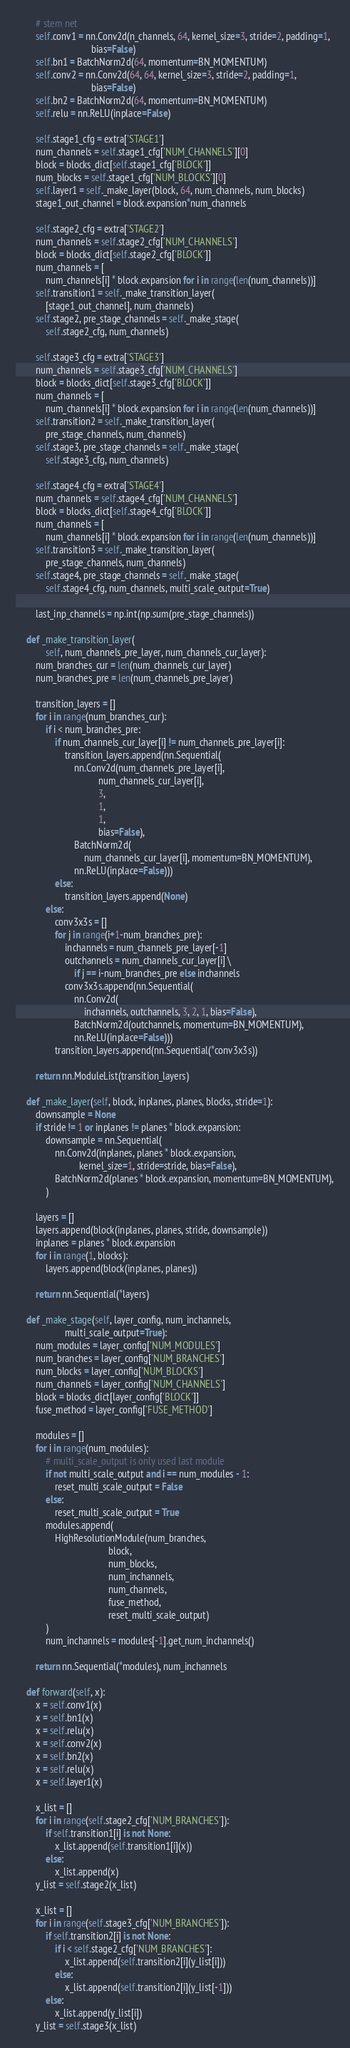<code> <loc_0><loc_0><loc_500><loc_500><_Python_>
        # stem net
        self.conv1 = nn.Conv2d(n_channels, 64, kernel_size=3, stride=2, padding=1,
                               bias=False)
        self.bn1 = BatchNorm2d(64, momentum=BN_MOMENTUM)
        self.conv2 = nn.Conv2d(64, 64, kernel_size=3, stride=2, padding=1,
                               bias=False)
        self.bn2 = BatchNorm2d(64, momentum=BN_MOMENTUM)
        self.relu = nn.ReLU(inplace=False)

        self.stage1_cfg = extra['STAGE1']
        num_channels = self.stage1_cfg['NUM_CHANNELS'][0]
        block = blocks_dict[self.stage1_cfg['BLOCK']]
        num_blocks = self.stage1_cfg['NUM_BLOCKS'][0]
        self.layer1 = self._make_layer(block, 64, num_channels, num_blocks)
        stage1_out_channel = block.expansion*num_channels

        self.stage2_cfg = extra['STAGE2']
        num_channels = self.stage2_cfg['NUM_CHANNELS']
        block = blocks_dict[self.stage2_cfg['BLOCK']]
        num_channels = [
            num_channels[i] * block.expansion for i in range(len(num_channels))]
        self.transition1 = self._make_transition_layer(
            [stage1_out_channel], num_channels)
        self.stage2, pre_stage_channels = self._make_stage(
            self.stage2_cfg, num_channels)

        self.stage3_cfg = extra['STAGE3']
        num_channels = self.stage3_cfg['NUM_CHANNELS']
        block = blocks_dict[self.stage3_cfg['BLOCK']]
        num_channels = [
            num_channels[i] * block.expansion for i in range(len(num_channels))]
        self.transition2 = self._make_transition_layer(
            pre_stage_channels, num_channels)
        self.stage3, pre_stage_channels = self._make_stage(
            self.stage3_cfg, num_channels)

        self.stage4_cfg = extra['STAGE4']
        num_channels = self.stage4_cfg['NUM_CHANNELS']
        block = blocks_dict[self.stage4_cfg['BLOCK']]
        num_channels = [
            num_channels[i] * block.expansion for i in range(len(num_channels))]
        self.transition3 = self._make_transition_layer(
            pre_stage_channels, num_channels)
        self.stage4, pre_stage_channels = self._make_stage(
            self.stage4_cfg, num_channels, multi_scale_output=True)
        
        last_inp_channels = np.int(np.sum(pre_stage_channels))
    
    def _make_transition_layer(
            self, num_channels_pre_layer, num_channels_cur_layer):
        num_branches_cur = len(num_channels_cur_layer)
        num_branches_pre = len(num_channels_pre_layer)

        transition_layers = []
        for i in range(num_branches_cur):
            if i < num_branches_pre:
                if num_channels_cur_layer[i] != num_channels_pre_layer[i]:
                    transition_layers.append(nn.Sequential(
                        nn.Conv2d(num_channels_pre_layer[i],
                                  num_channels_cur_layer[i],
                                  3,
                                  1,
                                  1,
                                  bias=False),
                        BatchNorm2d(
                            num_channels_cur_layer[i], momentum=BN_MOMENTUM),
                        nn.ReLU(inplace=False)))
                else:
                    transition_layers.append(None)
            else:
                conv3x3s = []
                for j in range(i+1-num_branches_pre):
                    inchannels = num_channels_pre_layer[-1]
                    outchannels = num_channels_cur_layer[i] \
                        if j == i-num_branches_pre else inchannels
                    conv3x3s.append(nn.Sequential(
                        nn.Conv2d(
                            inchannels, outchannels, 3, 2, 1, bias=False),
                        BatchNorm2d(outchannels, momentum=BN_MOMENTUM),
                        nn.ReLU(inplace=False)))
                transition_layers.append(nn.Sequential(*conv3x3s))

        return nn.ModuleList(transition_layers)

    def _make_layer(self, block, inplanes, planes, blocks, stride=1):
        downsample = None
        if stride != 1 or inplanes != planes * block.expansion:
            downsample = nn.Sequential(
                nn.Conv2d(inplanes, planes * block.expansion,
                          kernel_size=1, stride=stride, bias=False),
                BatchNorm2d(planes * block.expansion, momentum=BN_MOMENTUM),
            )

        layers = []
        layers.append(block(inplanes, planes, stride, downsample))
        inplanes = planes * block.expansion
        for i in range(1, blocks):
            layers.append(block(inplanes, planes))

        return nn.Sequential(*layers)

    def _make_stage(self, layer_config, num_inchannels,
                    multi_scale_output=True):
        num_modules = layer_config['NUM_MODULES']
        num_branches = layer_config['NUM_BRANCHES']
        num_blocks = layer_config['NUM_BLOCKS']
        num_channels = layer_config['NUM_CHANNELS']
        block = blocks_dict[layer_config['BLOCK']]
        fuse_method = layer_config['FUSE_METHOD']

        modules = []
        for i in range(num_modules):
            # multi_scale_output is only used last module
            if not multi_scale_output and i == num_modules - 1:
                reset_multi_scale_output = False
            else:
                reset_multi_scale_output = True
            modules.append(
                HighResolutionModule(num_branches,
                                      block,
                                      num_blocks,
                                      num_inchannels,
                                      num_channels,
                                      fuse_method,
                                      reset_multi_scale_output)
            )
            num_inchannels = modules[-1].get_num_inchannels()

        return nn.Sequential(*modules), num_inchannels

    def forward(self, x):
        x = self.conv1(x)
        x = self.bn1(x)
        x = self.relu(x)
        x = self.conv2(x)
        x = self.bn2(x)
        x = self.relu(x)
        x = self.layer1(x)

        x_list = []
        for i in range(self.stage2_cfg['NUM_BRANCHES']):
            if self.transition1[i] is not None:
                x_list.append(self.transition1[i](x))
            else:
                x_list.append(x)
        y_list = self.stage2(x_list)

        x_list = []
        for i in range(self.stage3_cfg['NUM_BRANCHES']):
            if self.transition2[i] is not None:
                if i < self.stage2_cfg['NUM_BRANCHES']:
                    x_list.append(self.transition2[i](y_list[i]))
                else:
                    x_list.append(self.transition2[i](y_list[-1]))
            else:
                x_list.append(y_list[i])
        y_list = self.stage3(x_list)
</code> 